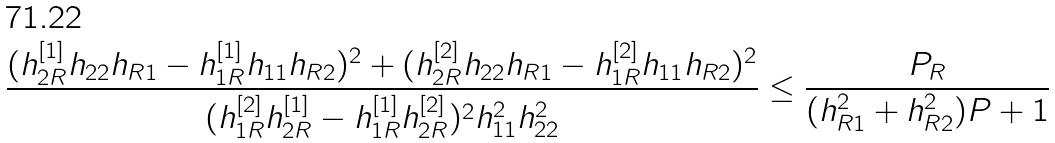<formula> <loc_0><loc_0><loc_500><loc_500>\frac { ( h _ { 2 R } ^ { [ 1 ] } h _ { 2 2 } h _ { R 1 } - h _ { 1 R } ^ { [ 1 ] } h _ { 1 1 } h _ { R 2 } ) ^ { 2 } + ( h _ { 2 R } ^ { [ 2 ] } h _ { 2 2 } h _ { R 1 } - h _ { 1 R } ^ { [ 2 ] } h _ { 1 1 } h _ { R 2 } ) ^ { 2 } } { ( h _ { 1 R } ^ { [ 2 ] } h _ { 2 R } ^ { [ 1 ] } - h _ { 1 R } ^ { [ 1 ] } h _ { 2 R } ^ { [ 2 ] } ) ^ { 2 } h _ { 1 1 } ^ { 2 } h _ { 2 2 } ^ { 2 } } \leq \frac { P _ { R } } { ( h _ { R 1 } ^ { 2 } + h _ { R 2 } ^ { 2 } ) P + 1 }</formula> 